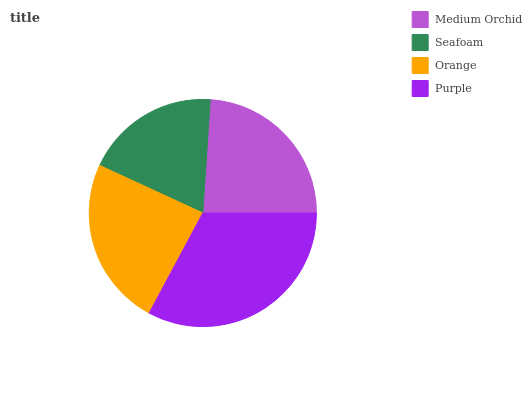Is Seafoam the minimum?
Answer yes or no. Yes. Is Purple the maximum?
Answer yes or no. Yes. Is Orange the minimum?
Answer yes or no. No. Is Orange the maximum?
Answer yes or no. No. Is Orange greater than Seafoam?
Answer yes or no. Yes. Is Seafoam less than Orange?
Answer yes or no. Yes. Is Seafoam greater than Orange?
Answer yes or no. No. Is Orange less than Seafoam?
Answer yes or no. No. Is Orange the high median?
Answer yes or no. Yes. Is Medium Orchid the low median?
Answer yes or no. Yes. Is Medium Orchid the high median?
Answer yes or no. No. Is Orange the low median?
Answer yes or no. No. 